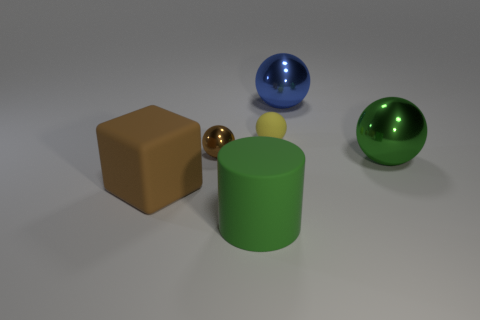Subtract 1 spheres. How many spheres are left? 3 Add 1 matte things. How many objects exist? 7 Subtract all balls. How many objects are left? 2 Add 2 large gray things. How many large gray things exist? 2 Subtract 0 brown cylinders. How many objects are left? 6 Subtract all big gray rubber cubes. Subtract all yellow matte objects. How many objects are left? 5 Add 3 green shiny objects. How many green shiny objects are left? 4 